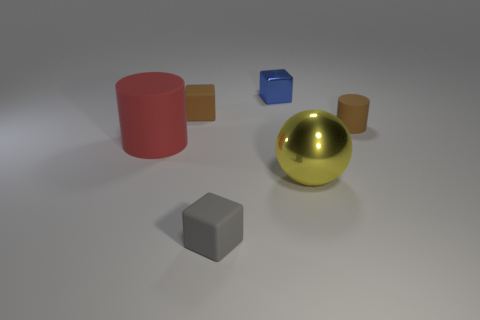How would you describe the material and finish of the golden sphere? The golden sphere has a reflective, polished finish, suggesting it could be made of a metal like brass or gold, giving it a smooth and shiny appearance. 